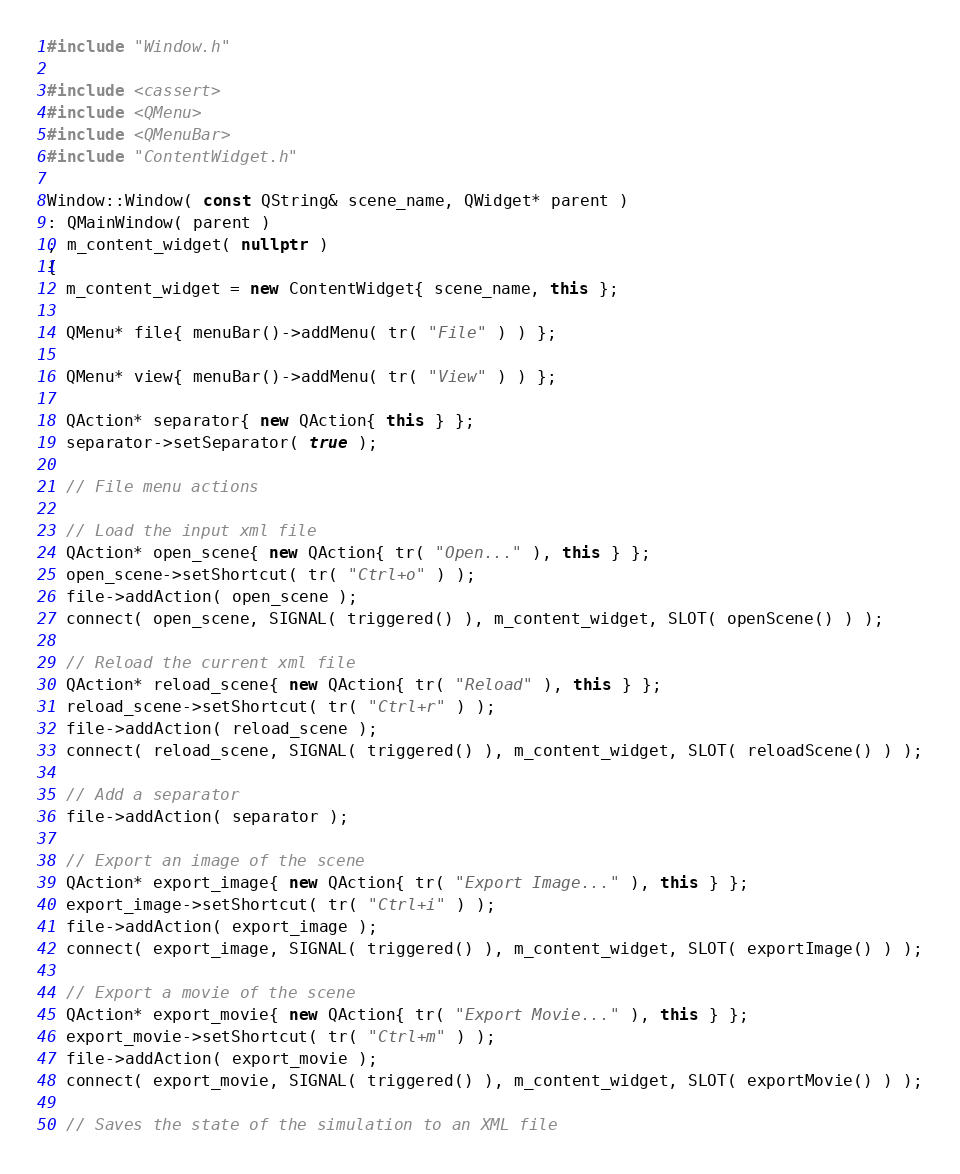Convert code to text. <code><loc_0><loc_0><loc_500><loc_500><_C++_>#include "Window.h"

#include <cassert>
#include <QMenu>
#include <QMenuBar>
#include "ContentWidget.h"

Window::Window( const QString& scene_name, QWidget* parent )
: QMainWindow( parent )
, m_content_widget( nullptr )
{
  m_content_widget = new ContentWidget{ scene_name, this };

  QMenu* file{ menuBar()->addMenu( tr( "File" ) ) };

  QMenu* view{ menuBar()->addMenu( tr( "View" ) ) };
  
  QAction* separator{ new QAction{ this } };
  separator->setSeparator( true );

  // File menu actions

  // Load the input xml file
  QAction* open_scene{ new QAction{ tr( "Open..." ), this } };
  open_scene->setShortcut( tr( "Ctrl+o" ) );
  file->addAction( open_scene );
  connect( open_scene, SIGNAL( triggered() ), m_content_widget, SLOT( openScene() ) );

  // Reload the current xml file
  QAction* reload_scene{ new QAction{ tr( "Reload" ), this } };
  reload_scene->setShortcut( tr( "Ctrl+r" ) );
  file->addAction( reload_scene );
  connect( reload_scene, SIGNAL( triggered() ), m_content_widget, SLOT( reloadScene() ) );

  // Add a separator
  file->addAction( separator );

  // Export an image of the scene
  QAction* export_image{ new QAction{ tr( "Export Image..." ), this } };
  export_image->setShortcut( tr( "Ctrl+i" ) );
  file->addAction( export_image );
  connect( export_image, SIGNAL( triggered() ), m_content_widget, SLOT( exportImage() ) );

  // Export a movie of the scene
  QAction* export_movie{ new QAction{ tr( "Export Movie..." ), this } };
  export_movie->setShortcut( tr( "Ctrl+m" ) );
  file->addAction( export_movie );
  connect( export_movie, SIGNAL( triggered() ), m_content_widget, SLOT( exportMovie() ) );

  // Saves the state of the simulation to an XML file</code> 